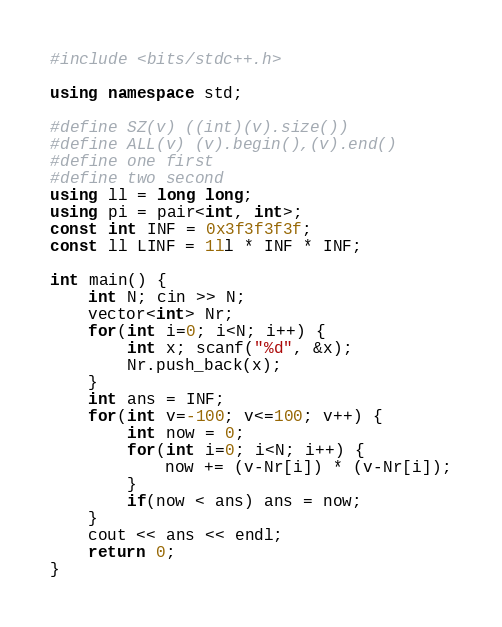<code> <loc_0><loc_0><loc_500><loc_500><_C++_>#include <bits/stdc++.h>

using namespace std;

#define SZ(v) ((int)(v).size())
#define ALL(v) (v).begin(),(v).end()
#define one first
#define two second
using ll = long long;
using pi = pair<int, int>;
const int INF = 0x3f3f3f3f;
const ll LINF = 1ll * INF * INF;

int main() {
	int N; cin >> N;
	vector<int> Nr;
	for(int i=0; i<N; i++) {
		int x; scanf("%d", &x);
		Nr.push_back(x);
	}
	int ans = INF;
	for(int v=-100; v<=100; v++) {
		int now = 0;
		for(int i=0; i<N; i++) {
			now += (v-Nr[i]) * (v-Nr[i]);
		}
		if(now < ans) ans = now;
	}
	cout << ans << endl;
	return 0;
}
</code> 